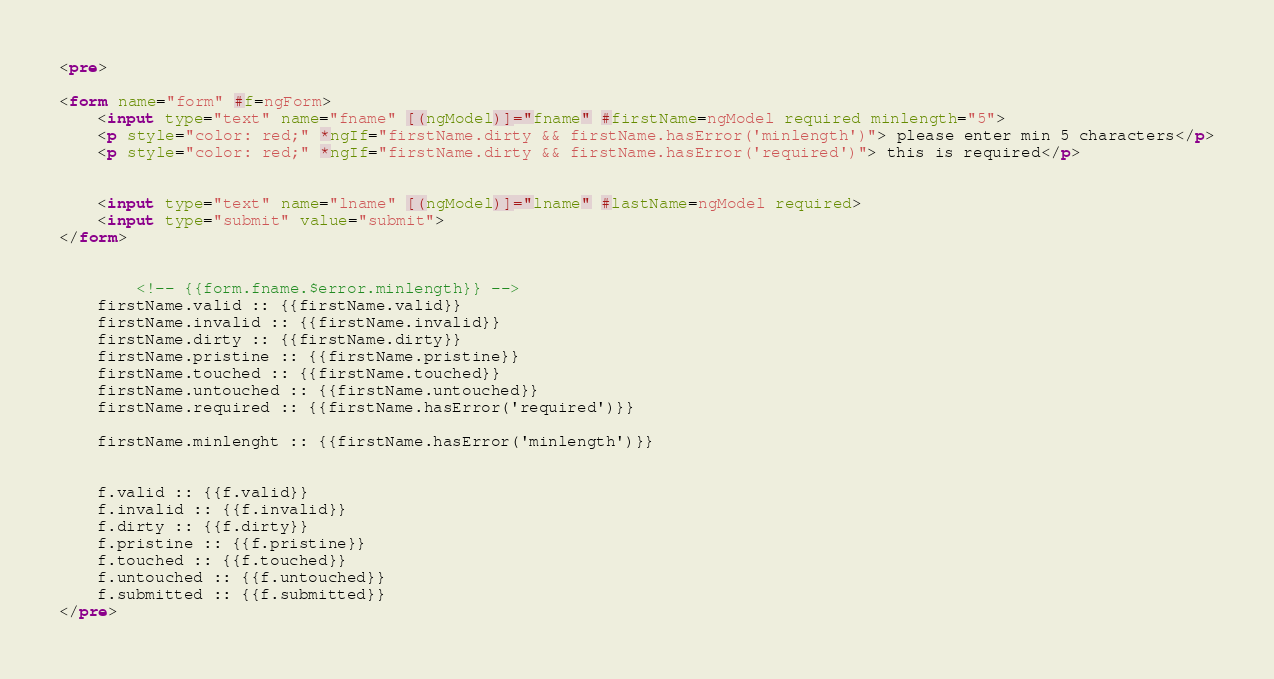Convert code to text. <code><loc_0><loc_0><loc_500><loc_500><_HTML_><pre>

<form name="form" #f=ngForm>
	<input type="text" name="fname" [(ngModel)]="fname" #firstName=ngModel required minlength="5"> 
	<p style="color: red;" *ngIf="firstName.dirty && firstName.hasError('minlength')"> please enter min 5 characters</p>
	<p style="color: red;" *ngIf="firstName.dirty && firstName.hasError('required')"> this is required</p>

	
	<input type="text" name="lname" [(ngModel)]="lname" #lastName=ngModel required> 
	<input type="submit" value="submit">
</form>


		<!-- {{form.fname.$error.minlength}} -->
	firstName.valid :: {{firstName.valid}}
	firstName.invalid :: {{firstName.invalid}}
	firstName.dirty :: {{firstName.dirty}}
	firstName.pristine :: {{firstName.pristine}}
	firstName.touched :: {{firstName.touched}}
	firstName.untouched :: {{firstName.untouched}}
	firstName.required :: {{firstName.hasError('required')}}

	firstName.minlenght :: {{firstName.hasError('minlength')}}


	f.valid :: {{f.valid}}
	f.invalid :: {{f.invalid}}
	f.dirty :: {{f.dirty}}
	f.pristine :: {{f.pristine}}
	f.touched :: {{f.touched}}
	f.untouched :: {{f.untouched}}
	f.submitted :: {{f.submitted}}
</pre></code> 